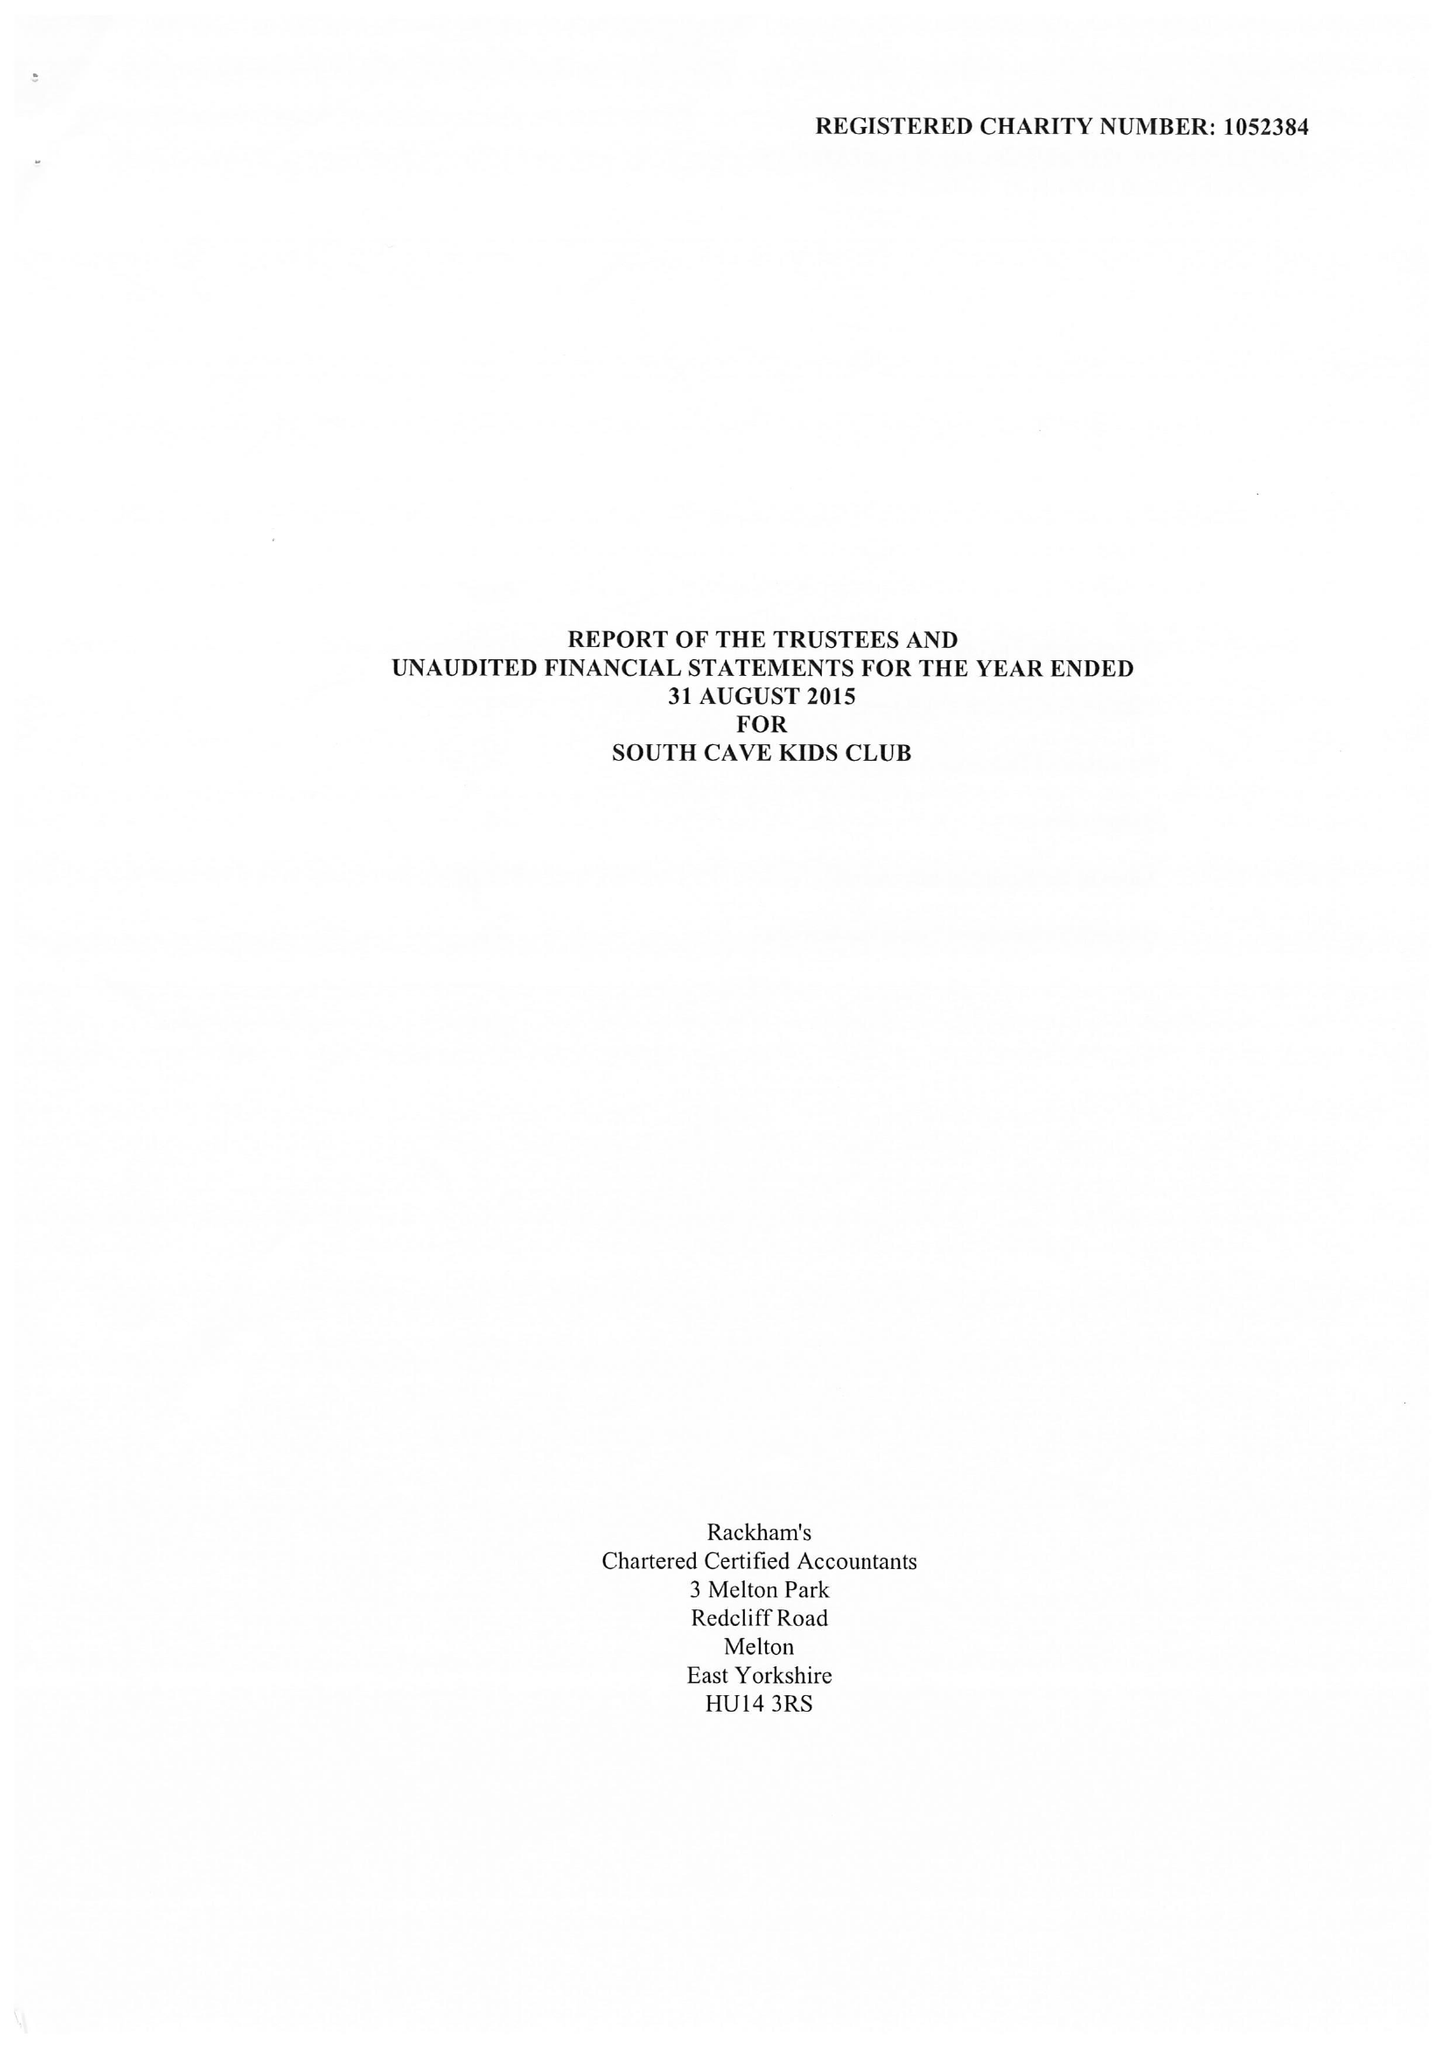What is the value for the income_annually_in_british_pounds?
Answer the question using a single word or phrase. 115962.00 